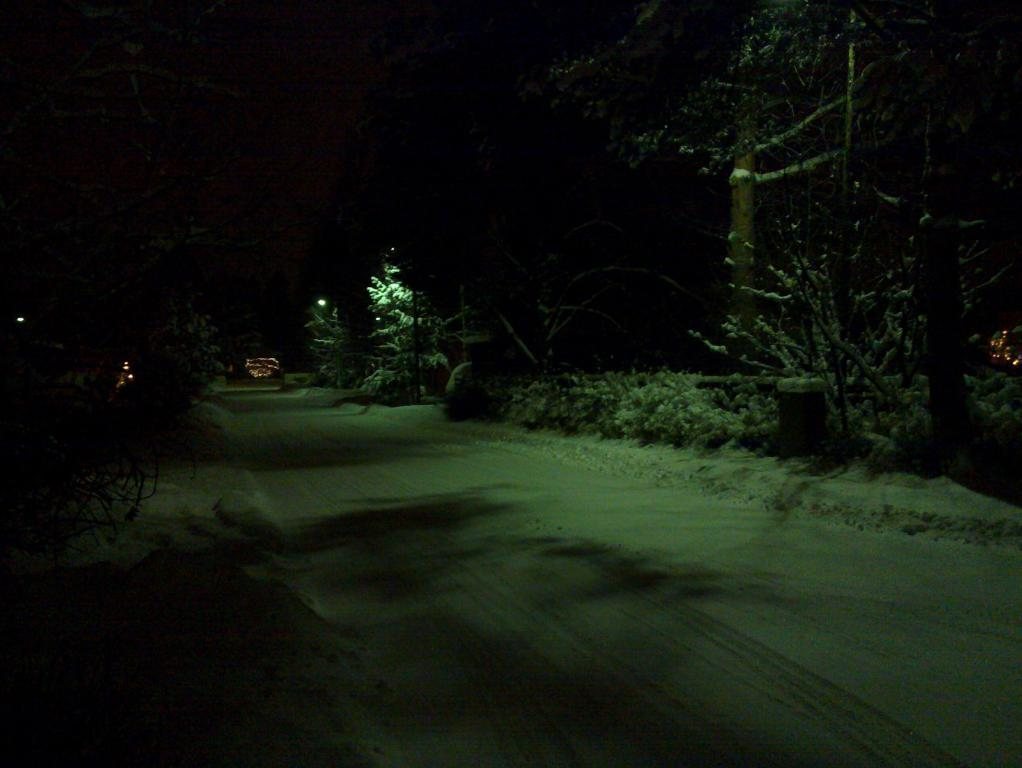What is at the bottom of the image? There is ground at the bottom of the image. What can be seen in the background of the image? There are trees in the background of the image. Can you see anyone swimming in the image? There is no water or swimming activity depicted in the image. What type of clam is visible on the ground in the image? There are no clams present in the image; it features ground and trees. 